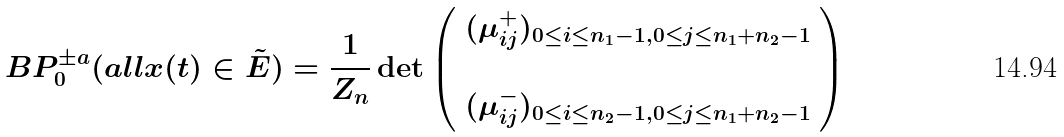Convert formula to latex. <formula><loc_0><loc_0><loc_500><loc_500>\ B P _ { 0 } ^ { \pm a } ( a l l x ( t ) \in \tilde { E } ) = \frac { 1 } { Z _ { n } } \det \left ( \begin{array} { l } ( \mu _ { i j } ^ { + } ) _ { 0 \leq i \leq n _ { 1 } - 1 , 0 \leq j \leq n _ { 1 } + n _ { 2 } - 1 } \\ \\ ( \mu _ { i j } ^ { - } ) _ { 0 \leq i \leq n _ { 2 } - 1 , 0 \leq j \leq n _ { 1 } + n _ { 2 } - 1 } \\ \end{array} \right )</formula> 